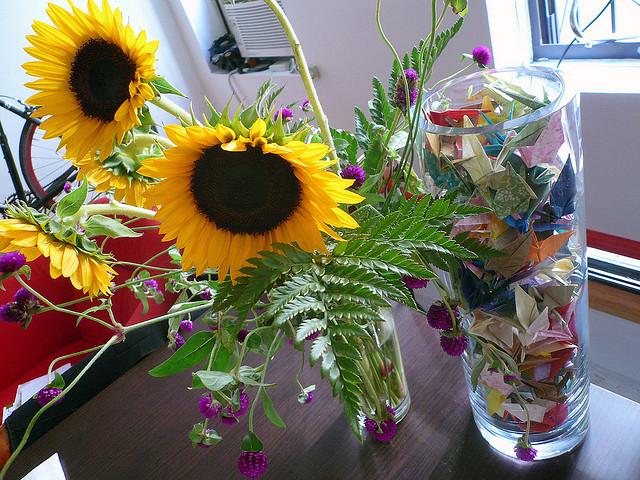What is in the vase next to the flowers?
Short answer required. Paper. Is there more than one vase on the table?
Answer briefly. Yes. Are these flowers real or silk?
Short answer required. Real. England's Queen mother and these blooms share what syllable?
Quick response, please. Sun. 